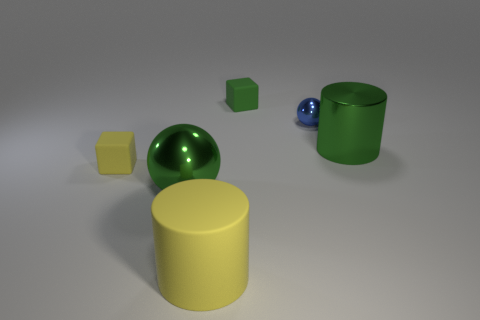The big thing that is made of the same material as the tiny green object is what shape? The larger object that shares the same material as the small green cube appears to be cylindrical in shape, with a circular base and a smooth, curved surface extending vertically. 